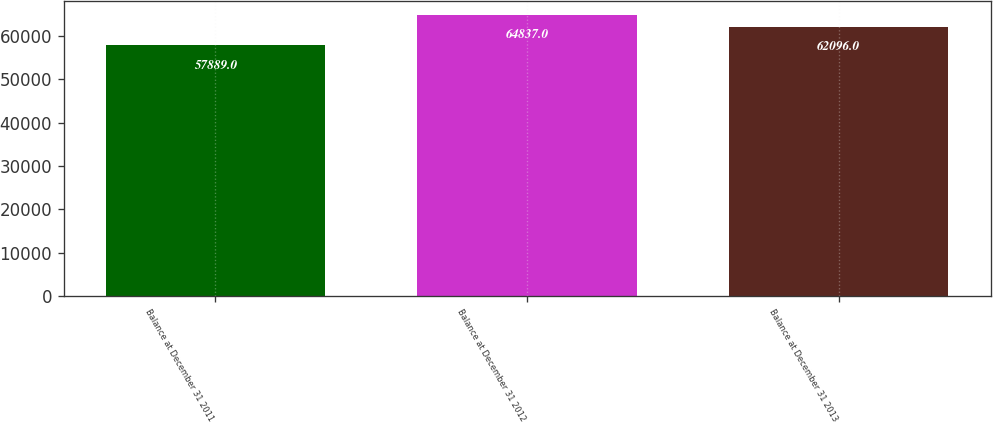Convert chart to OTSL. <chart><loc_0><loc_0><loc_500><loc_500><bar_chart><fcel>Balance at December 31 2011<fcel>Balance at December 31 2012<fcel>Balance at December 31 2013<nl><fcel>57889<fcel>64837<fcel>62096<nl></chart> 